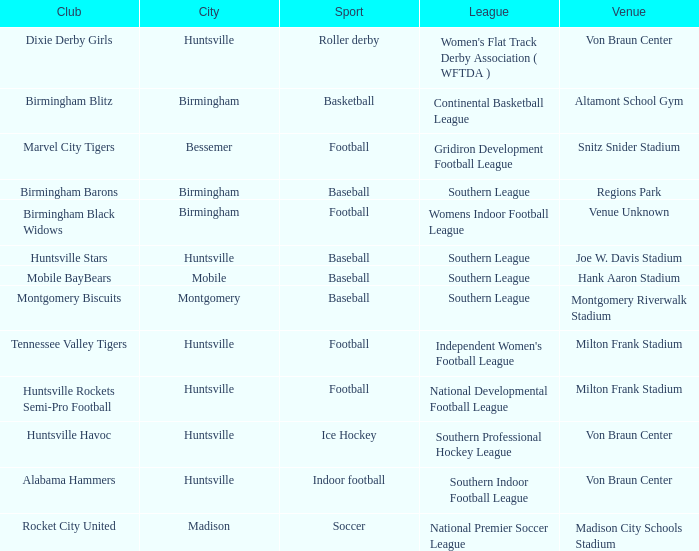In which city is a club named the huntsville stars located? Huntsville. 